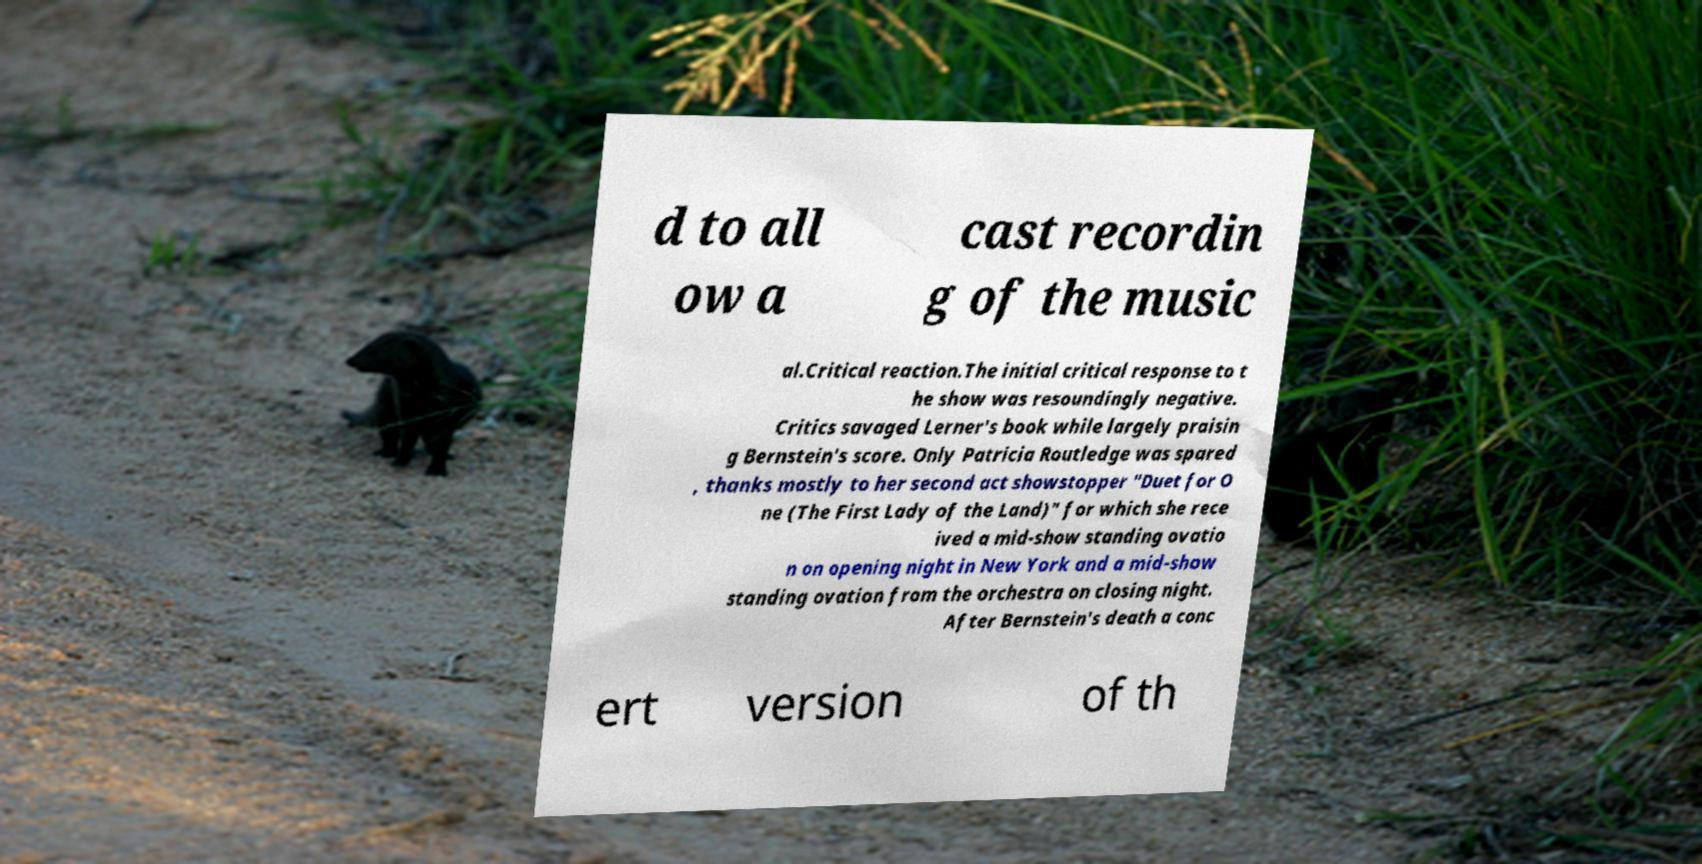Could you extract and type out the text from this image? d to all ow a cast recordin g of the music al.Critical reaction.The initial critical response to t he show was resoundingly negative. Critics savaged Lerner's book while largely praisin g Bernstein's score. Only Patricia Routledge was spared , thanks mostly to her second act showstopper "Duet for O ne (The First Lady of the Land)" for which she rece ived a mid-show standing ovatio n on opening night in New York and a mid-show standing ovation from the orchestra on closing night. After Bernstein's death a conc ert version of th 